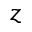Convert formula to latex. <formula><loc_0><loc_0><loc_500><loc_500>z</formula> 